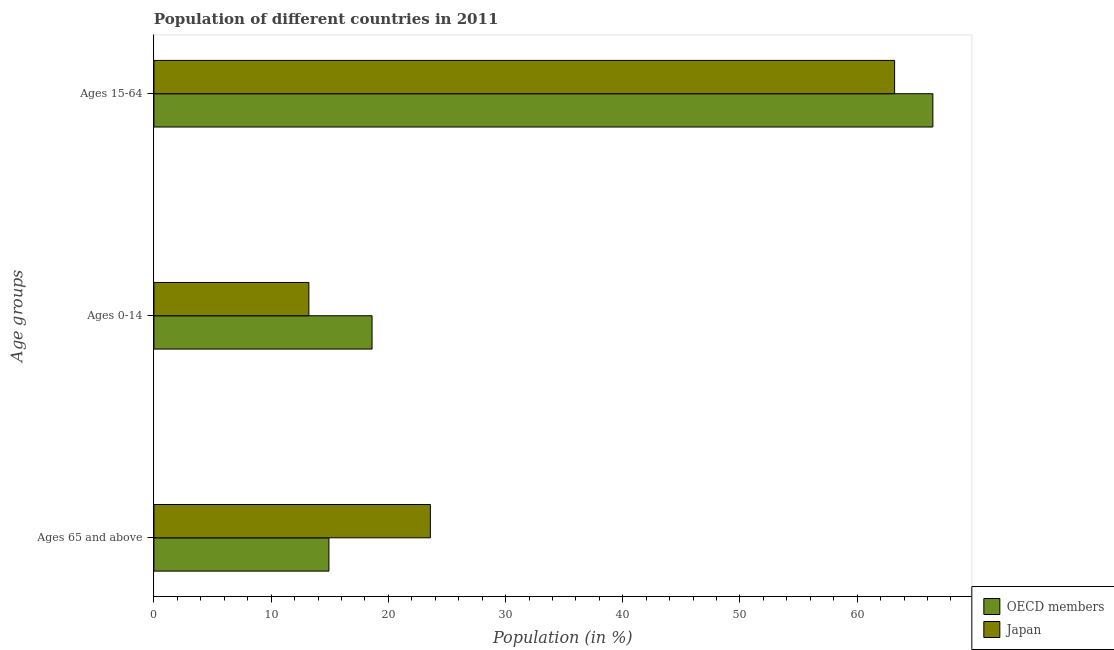How many different coloured bars are there?
Provide a succinct answer. 2. How many groups of bars are there?
Give a very brief answer. 3. Are the number of bars on each tick of the Y-axis equal?
Make the answer very short. Yes. How many bars are there on the 1st tick from the top?
Provide a succinct answer. 2. How many bars are there on the 2nd tick from the bottom?
Provide a short and direct response. 2. What is the label of the 3rd group of bars from the top?
Keep it short and to the point. Ages 65 and above. What is the percentage of population within the age-group of 65 and above in Japan?
Offer a terse response. 23.59. Across all countries, what is the maximum percentage of population within the age-group 15-64?
Provide a succinct answer. 66.46. Across all countries, what is the minimum percentage of population within the age-group 15-64?
Give a very brief answer. 63.19. In which country was the percentage of population within the age-group 15-64 maximum?
Offer a terse response. OECD members. In which country was the percentage of population within the age-group of 65 and above minimum?
Give a very brief answer. OECD members. What is the total percentage of population within the age-group 15-64 in the graph?
Give a very brief answer. 129.65. What is the difference between the percentage of population within the age-group 15-64 in Japan and that in OECD members?
Offer a very short reply. -3.27. What is the difference between the percentage of population within the age-group of 65 and above in Japan and the percentage of population within the age-group 0-14 in OECD members?
Your response must be concise. 4.98. What is the average percentage of population within the age-group 15-64 per country?
Keep it short and to the point. 64.83. What is the difference between the percentage of population within the age-group 15-64 and percentage of population within the age-group 0-14 in OECD members?
Provide a short and direct response. 47.85. What is the ratio of the percentage of population within the age-group 15-64 in OECD members to that in Japan?
Make the answer very short. 1.05. Is the percentage of population within the age-group of 65 and above in OECD members less than that in Japan?
Offer a terse response. Yes. What is the difference between the highest and the second highest percentage of population within the age-group 0-14?
Give a very brief answer. 5.39. What is the difference between the highest and the lowest percentage of population within the age-group of 65 and above?
Give a very brief answer. 8.66. In how many countries, is the percentage of population within the age-group 0-14 greater than the average percentage of population within the age-group 0-14 taken over all countries?
Provide a short and direct response. 1. Is the sum of the percentage of population within the age-group of 65 and above in OECD members and Japan greater than the maximum percentage of population within the age-group 15-64 across all countries?
Offer a terse response. No. What does the 1st bar from the top in Ages 15-64 represents?
Offer a terse response. Japan. Are all the bars in the graph horizontal?
Your answer should be very brief. Yes. How many countries are there in the graph?
Make the answer very short. 2. Are the values on the major ticks of X-axis written in scientific E-notation?
Provide a short and direct response. No. Does the graph contain any zero values?
Your answer should be compact. No. How many legend labels are there?
Make the answer very short. 2. What is the title of the graph?
Offer a terse response. Population of different countries in 2011. What is the label or title of the Y-axis?
Give a very brief answer. Age groups. What is the Population (in %) of OECD members in Ages 65 and above?
Give a very brief answer. 14.93. What is the Population (in %) in Japan in Ages 65 and above?
Make the answer very short. 23.59. What is the Population (in %) of OECD members in Ages 0-14?
Your answer should be very brief. 18.61. What is the Population (in %) of Japan in Ages 0-14?
Provide a succinct answer. 13.22. What is the Population (in %) of OECD members in Ages 15-64?
Make the answer very short. 66.46. What is the Population (in %) in Japan in Ages 15-64?
Offer a terse response. 63.19. Across all Age groups, what is the maximum Population (in %) in OECD members?
Provide a succinct answer. 66.46. Across all Age groups, what is the maximum Population (in %) in Japan?
Your response must be concise. 63.19. Across all Age groups, what is the minimum Population (in %) in OECD members?
Your answer should be very brief. 14.93. Across all Age groups, what is the minimum Population (in %) in Japan?
Keep it short and to the point. 13.22. What is the difference between the Population (in %) of OECD members in Ages 65 and above and that in Ages 0-14?
Provide a short and direct response. -3.68. What is the difference between the Population (in %) in Japan in Ages 65 and above and that in Ages 0-14?
Ensure brevity in your answer.  10.37. What is the difference between the Population (in %) of OECD members in Ages 65 and above and that in Ages 15-64?
Your answer should be very brief. -51.53. What is the difference between the Population (in %) in Japan in Ages 65 and above and that in Ages 15-64?
Offer a very short reply. -39.61. What is the difference between the Population (in %) in OECD members in Ages 0-14 and that in Ages 15-64?
Provide a succinct answer. -47.85. What is the difference between the Population (in %) of Japan in Ages 0-14 and that in Ages 15-64?
Ensure brevity in your answer.  -49.97. What is the difference between the Population (in %) in OECD members in Ages 65 and above and the Population (in %) in Japan in Ages 0-14?
Your answer should be very brief. 1.71. What is the difference between the Population (in %) in OECD members in Ages 65 and above and the Population (in %) in Japan in Ages 15-64?
Provide a succinct answer. -48.26. What is the difference between the Population (in %) in OECD members in Ages 0-14 and the Population (in %) in Japan in Ages 15-64?
Make the answer very short. -44.58. What is the average Population (in %) in OECD members per Age groups?
Make the answer very short. 33.33. What is the average Population (in %) of Japan per Age groups?
Provide a short and direct response. 33.33. What is the difference between the Population (in %) in OECD members and Population (in %) in Japan in Ages 65 and above?
Keep it short and to the point. -8.66. What is the difference between the Population (in %) in OECD members and Population (in %) in Japan in Ages 0-14?
Offer a very short reply. 5.39. What is the difference between the Population (in %) of OECD members and Population (in %) of Japan in Ages 15-64?
Keep it short and to the point. 3.27. What is the ratio of the Population (in %) in OECD members in Ages 65 and above to that in Ages 0-14?
Keep it short and to the point. 0.8. What is the ratio of the Population (in %) in Japan in Ages 65 and above to that in Ages 0-14?
Keep it short and to the point. 1.78. What is the ratio of the Population (in %) of OECD members in Ages 65 and above to that in Ages 15-64?
Ensure brevity in your answer.  0.22. What is the ratio of the Population (in %) in Japan in Ages 65 and above to that in Ages 15-64?
Offer a terse response. 0.37. What is the ratio of the Population (in %) of OECD members in Ages 0-14 to that in Ages 15-64?
Your answer should be compact. 0.28. What is the ratio of the Population (in %) of Japan in Ages 0-14 to that in Ages 15-64?
Ensure brevity in your answer.  0.21. What is the difference between the highest and the second highest Population (in %) in OECD members?
Ensure brevity in your answer.  47.85. What is the difference between the highest and the second highest Population (in %) of Japan?
Provide a succinct answer. 39.61. What is the difference between the highest and the lowest Population (in %) of OECD members?
Provide a short and direct response. 51.53. What is the difference between the highest and the lowest Population (in %) in Japan?
Keep it short and to the point. 49.97. 